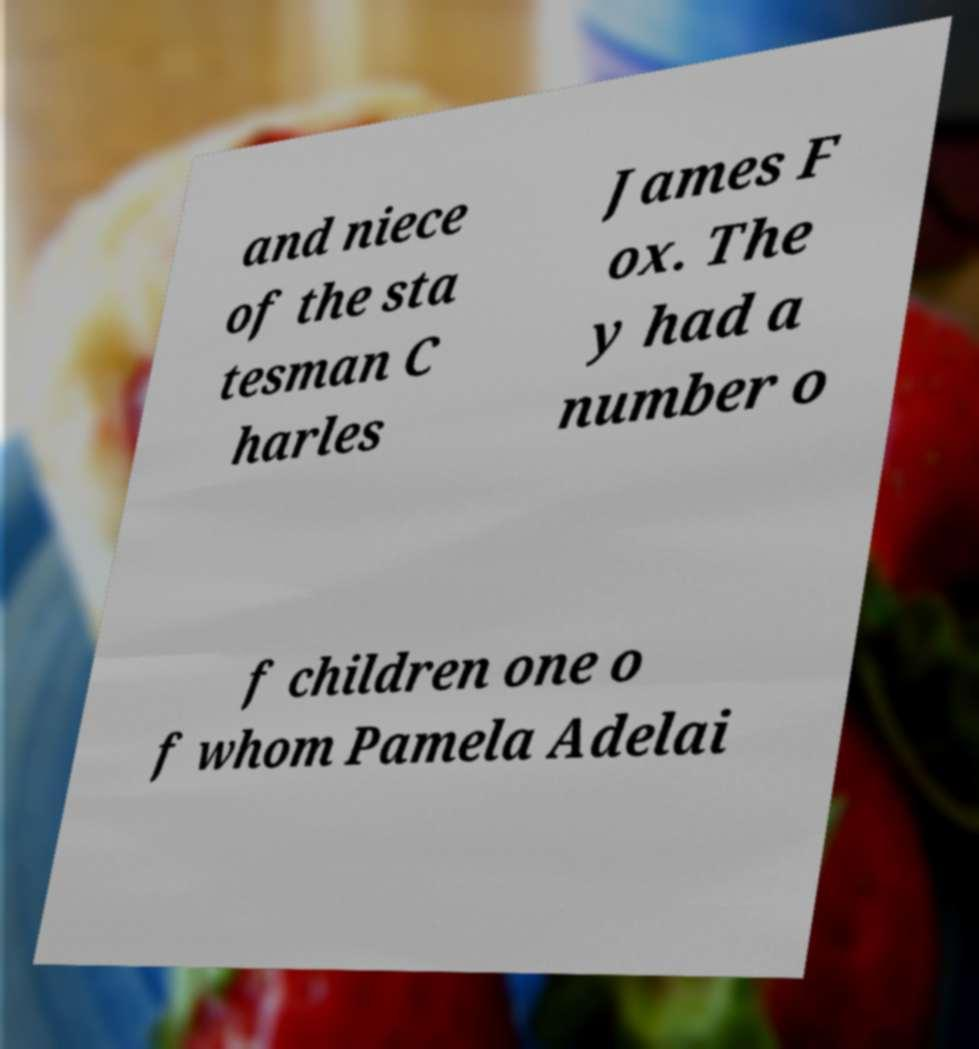Can you accurately transcribe the text from the provided image for me? and niece of the sta tesman C harles James F ox. The y had a number o f children one o f whom Pamela Adelai 